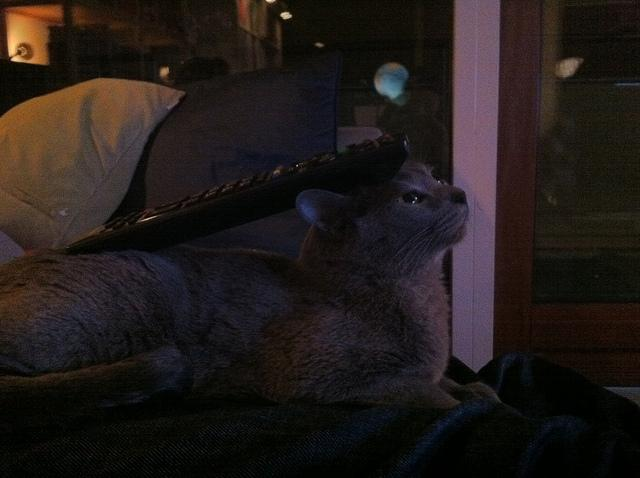What item is the cat balancing on their head? Please explain your reasoning. remote control. The item has lots of buttons on it common on that for changing channels and volume. 